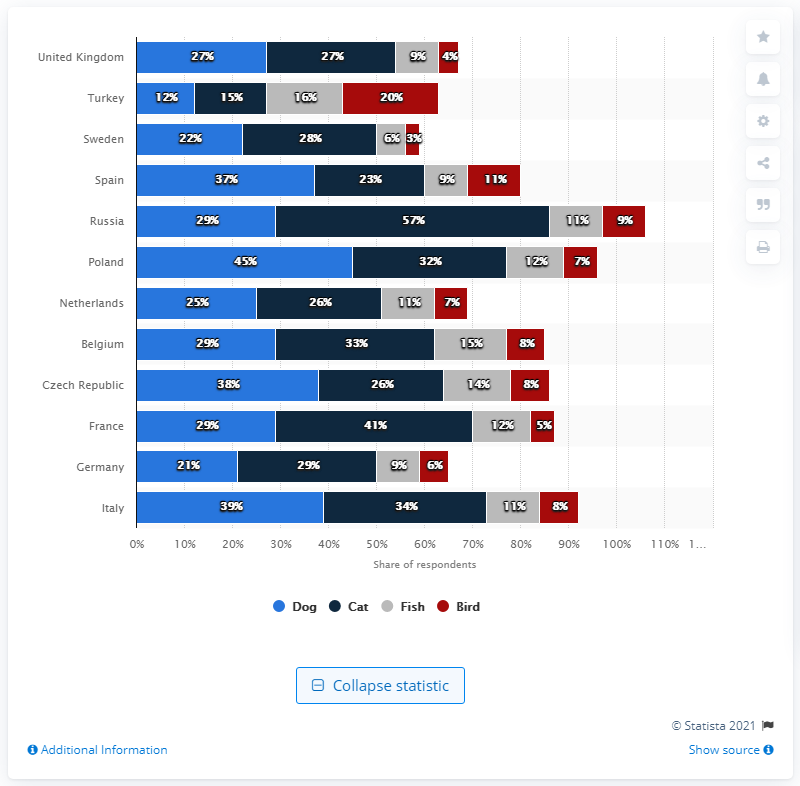Which country has the lowest ownership for birds, and what might this indicate about pet preferences? Germany has the lowest bird ownership at 6%, according to the graph. This could point to a preference for more interactive pets like cats and dogs, or it might reflect living conditions, as birds often require a quiet and stable environment, which might be less available in urban areas. 